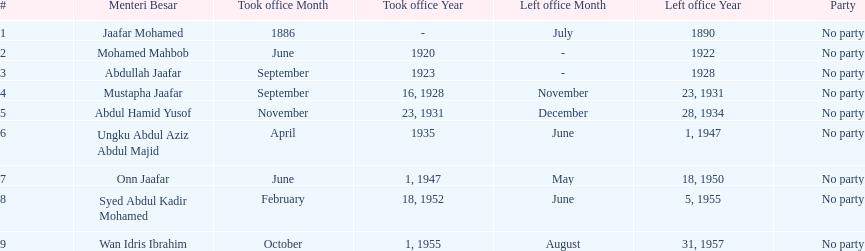What is the number of menteri besar that served 4 or more years? 3. Parse the table in full. {'header': ['#', 'Menteri Besar', 'Took office Month', 'Took office Year', 'Left office Month', 'Left office Year', 'Party'], 'rows': [['1', 'Jaafar Mohamed', '1886', '-', 'July', '1890', 'No party'], ['2', 'Mohamed Mahbob', 'June', '1920', '-', '1922', 'No party'], ['3', 'Abdullah Jaafar', 'September', '1923', '-', '1928', 'No party'], ['4', 'Mustapha Jaafar', 'September', '16, 1928', 'November', '23, 1931', 'No party'], ['5', 'Abdul Hamid Yusof', 'November', '23, 1931', 'December', '28, 1934', 'No party'], ['6', 'Ungku Abdul Aziz Abdul Majid', 'April', '1935', 'June', '1, 1947', 'No party'], ['7', 'Onn Jaafar', 'June', '1, 1947', 'May', '18, 1950', 'No party'], ['8', 'Syed Abdul Kadir Mohamed', 'February', '18, 1952', 'June', '5, 1955', 'No party'], ['9', 'Wan Idris Ibrahim', 'October', '1, 1955', 'August', '31, 1957', 'No party']]} 